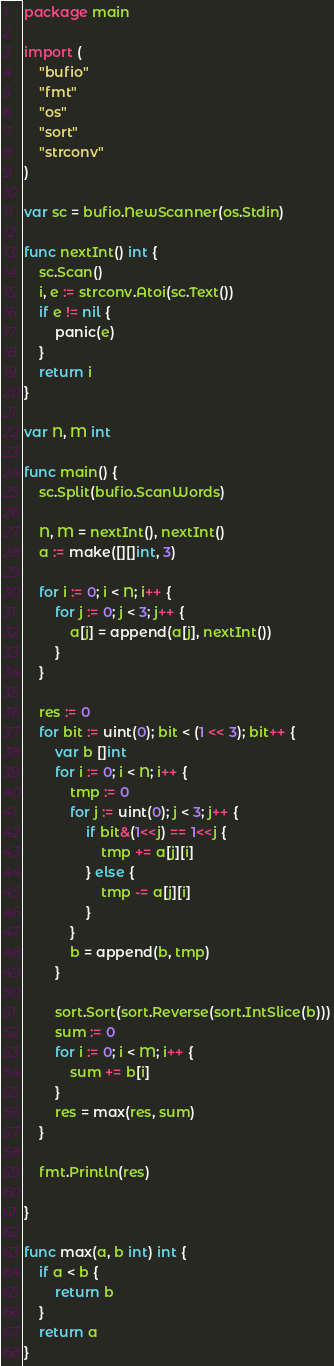<code> <loc_0><loc_0><loc_500><loc_500><_Go_>package main

import (
	"bufio"
	"fmt"
	"os"
	"sort"
	"strconv"
)

var sc = bufio.NewScanner(os.Stdin)

func nextInt() int {
	sc.Scan()
	i, e := strconv.Atoi(sc.Text())
	if e != nil {
		panic(e)
	}
	return i
}

var N, M int

func main() {
	sc.Split(bufio.ScanWords)

	N, M = nextInt(), nextInt()
	a := make([][]int, 3)

	for i := 0; i < N; i++ {
		for j := 0; j < 3; j++ {
			a[j] = append(a[j], nextInt())
		}
	}

	res := 0
	for bit := uint(0); bit < (1 << 3); bit++ {
		var b []int
		for i := 0; i < N; i++ {
			tmp := 0
			for j := uint(0); j < 3; j++ {
				if bit&(1<<j) == 1<<j {
					tmp += a[j][i]
				} else {
					tmp -= a[j][i]
				}
			}
			b = append(b, tmp)
		}

		sort.Sort(sort.Reverse(sort.IntSlice(b)))
		sum := 0
		for i := 0; i < M; i++ {
			sum += b[i]
		}
		res = max(res, sum)
	}

	fmt.Println(res)

}

func max(a, b int) int {
	if a < b {
		return b
	}
	return a
}
</code> 